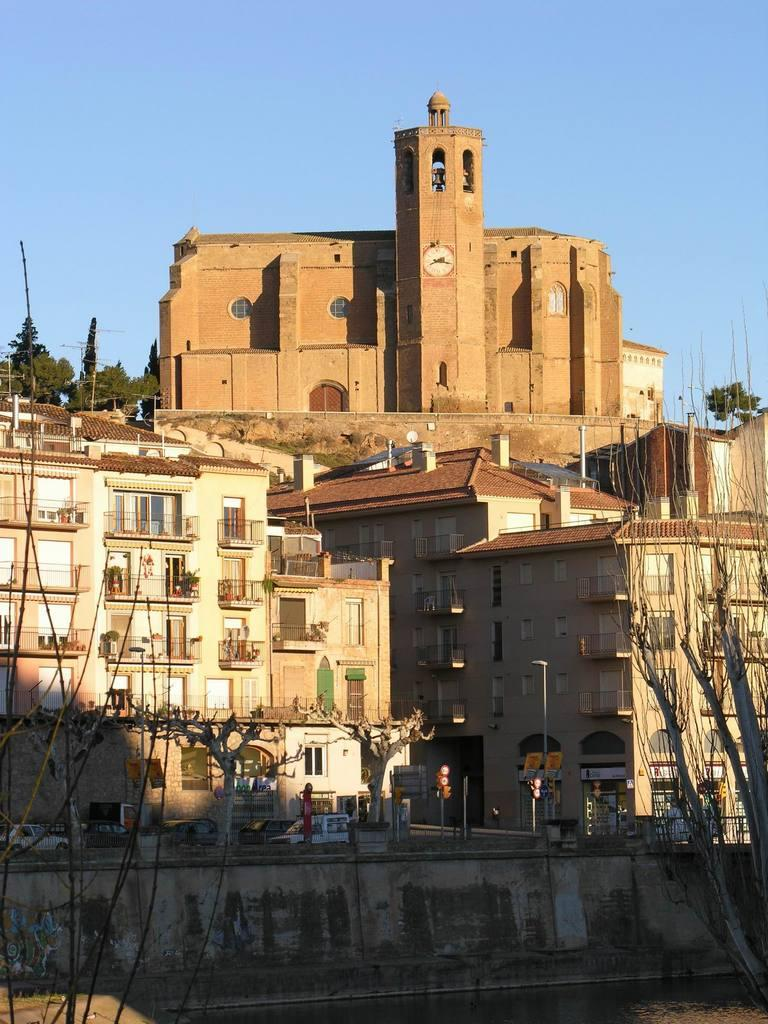What type of structures can be seen in the image? There are buildings in the image. What type of natural elements can be seen in the image? There are trees in the image. What type of man-made objects can be seen in the image? There are poles, vehicles, and boards in the image. What type of infrastructure is present in the image? There is a bridge in the image. What type of terrain is visible at the bottom of the image? There is water visible at the bottom of the image. What type of natural element is visible at the top of the image? There is sky visible at the top of the image. Can you tell me the name of the manager of the building in the image? There is no information about a manager of the building in the image. What type of point is being made by the trees in the image? The trees in the image are not making any point; they are simply part of the natural landscape. 